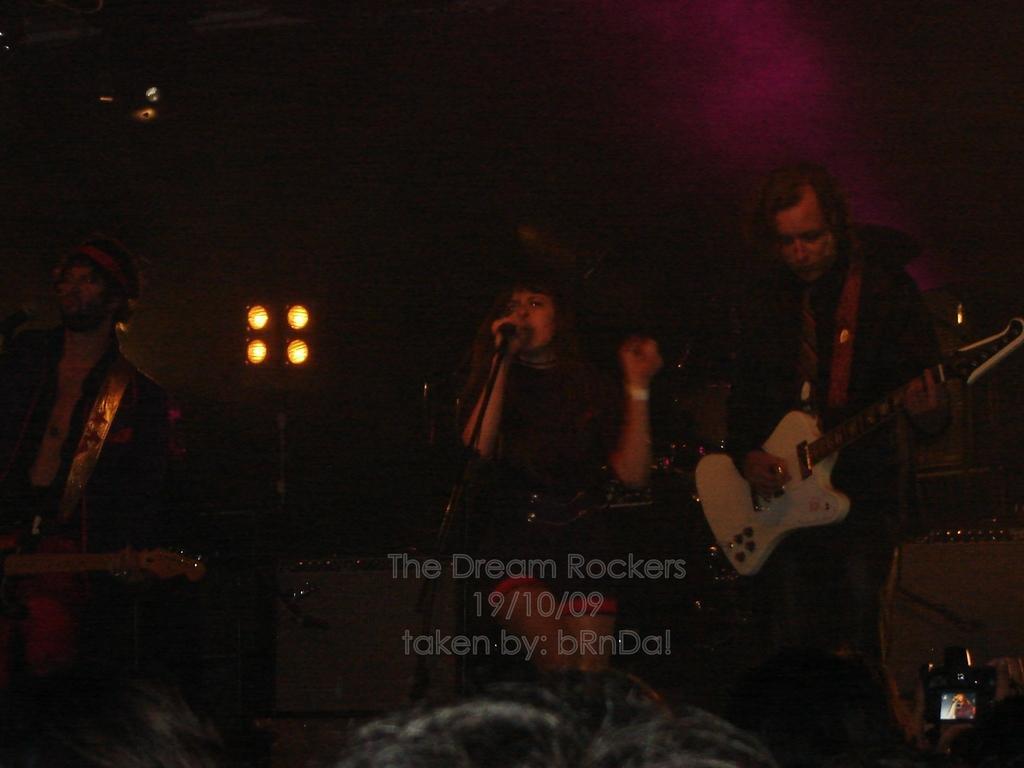Describe this image in one or two sentences. In this image, three peoples are standing. Few are playing a musical instrument. In the middle, woman is holding a microphone on his hand. At the background, we can see lights, stands. At the bottom of the image, we can see human heads. Here right side corner, we can see camera. 